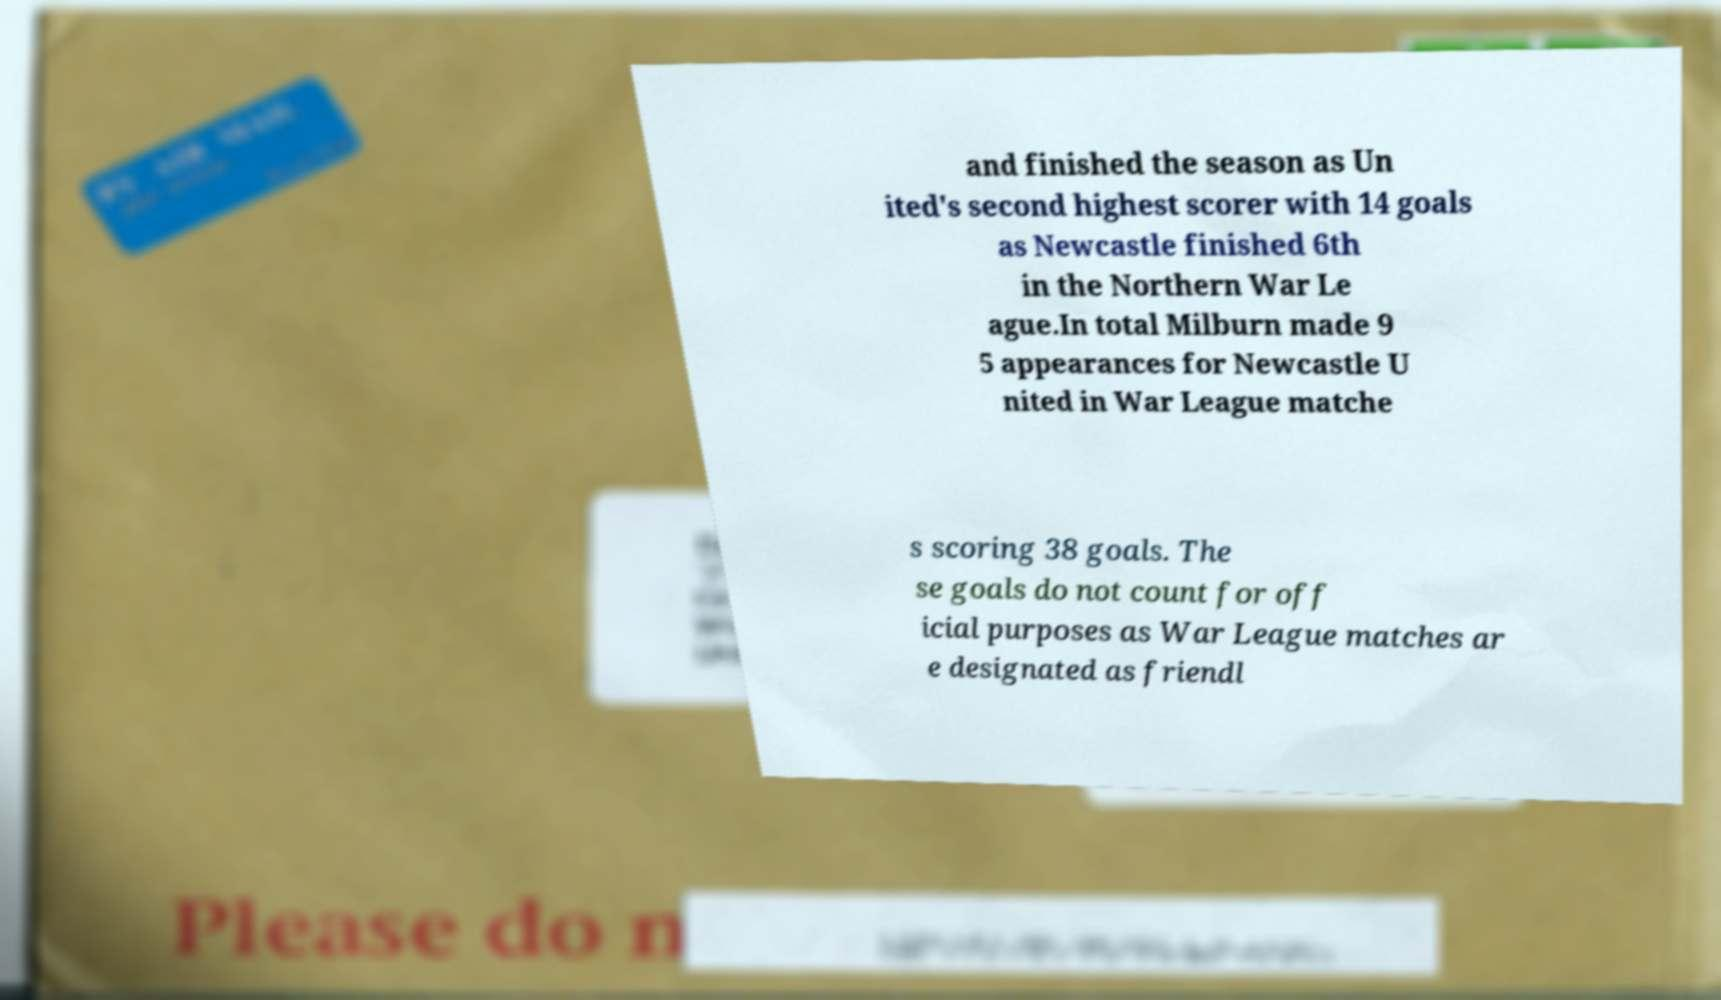Could you assist in decoding the text presented in this image and type it out clearly? and finished the season as Un ited's second highest scorer with 14 goals as Newcastle finished 6th in the Northern War Le ague.In total Milburn made 9 5 appearances for Newcastle U nited in War League matche s scoring 38 goals. The se goals do not count for off icial purposes as War League matches ar e designated as friendl 